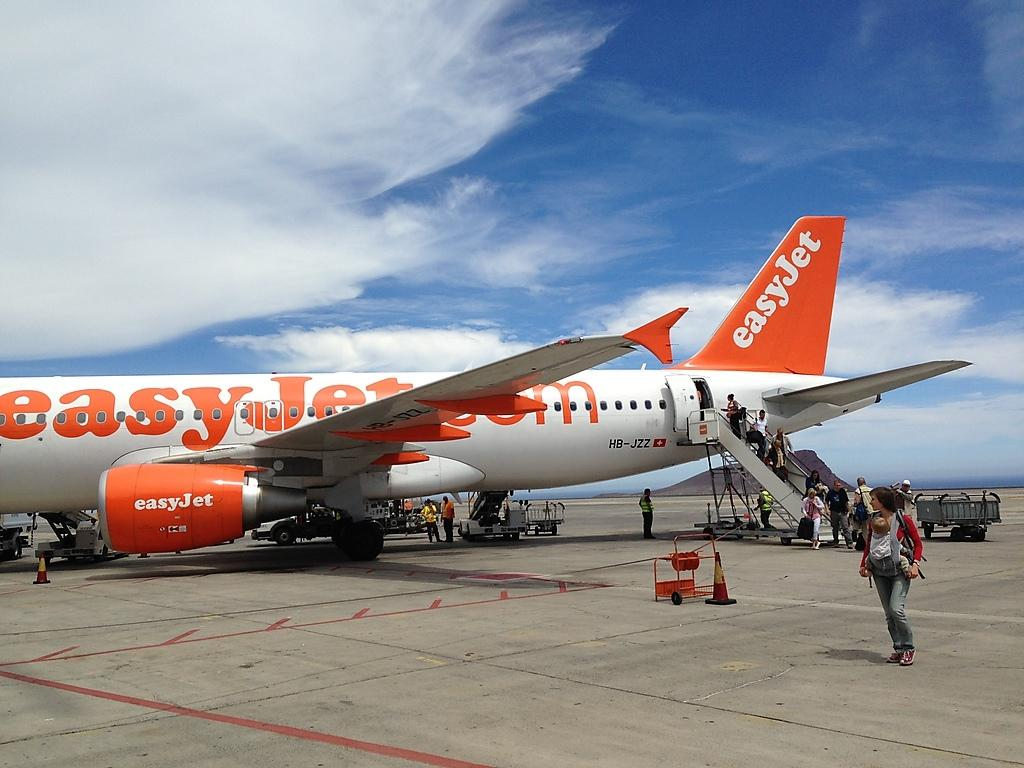Provide a one-sentence caption for the provided image. A woman with a baby walks away from an easyJet on a tarmac. 